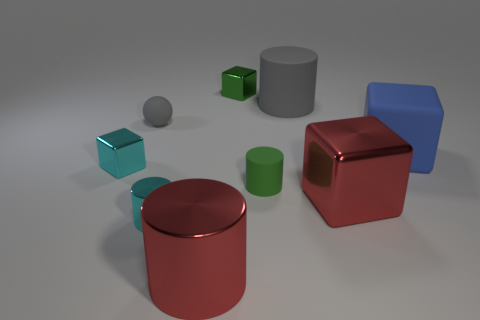Is the green matte cylinder the same size as the rubber cube?
Keep it short and to the point. No. What number of metallic objects are small things or big green balls?
Offer a terse response. 3. There is a red cube that is the same size as the red metal cylinder; what is it made of?
Offer a terse response. Metal. How many other things are there of the same material as the cyan cylinder?
Your answer should be compact. 4. Is the number of big rubber cylinders right of the cyan cylinder less than the number of small green objects?
Offer a very short reply. Yes. Is the shape of the small gray rubber object the same as the small green matte object?
Give a very brief answer. No. What size is the metal thing that is to the right of the gray object that is right of the gray thing in front of the gray cylinder?
Offer a very short reply. Large. There is a green thing that is the same shape as the blue matte thing; what material is it?
Provide a succinct answer. Metal. There is a rubber block that is in front of the block behind the big blue rubber thing; what is its size?
Your answer should be very brief. Large. What color is the small sphere?
Keep it short and to the point. Gray. 